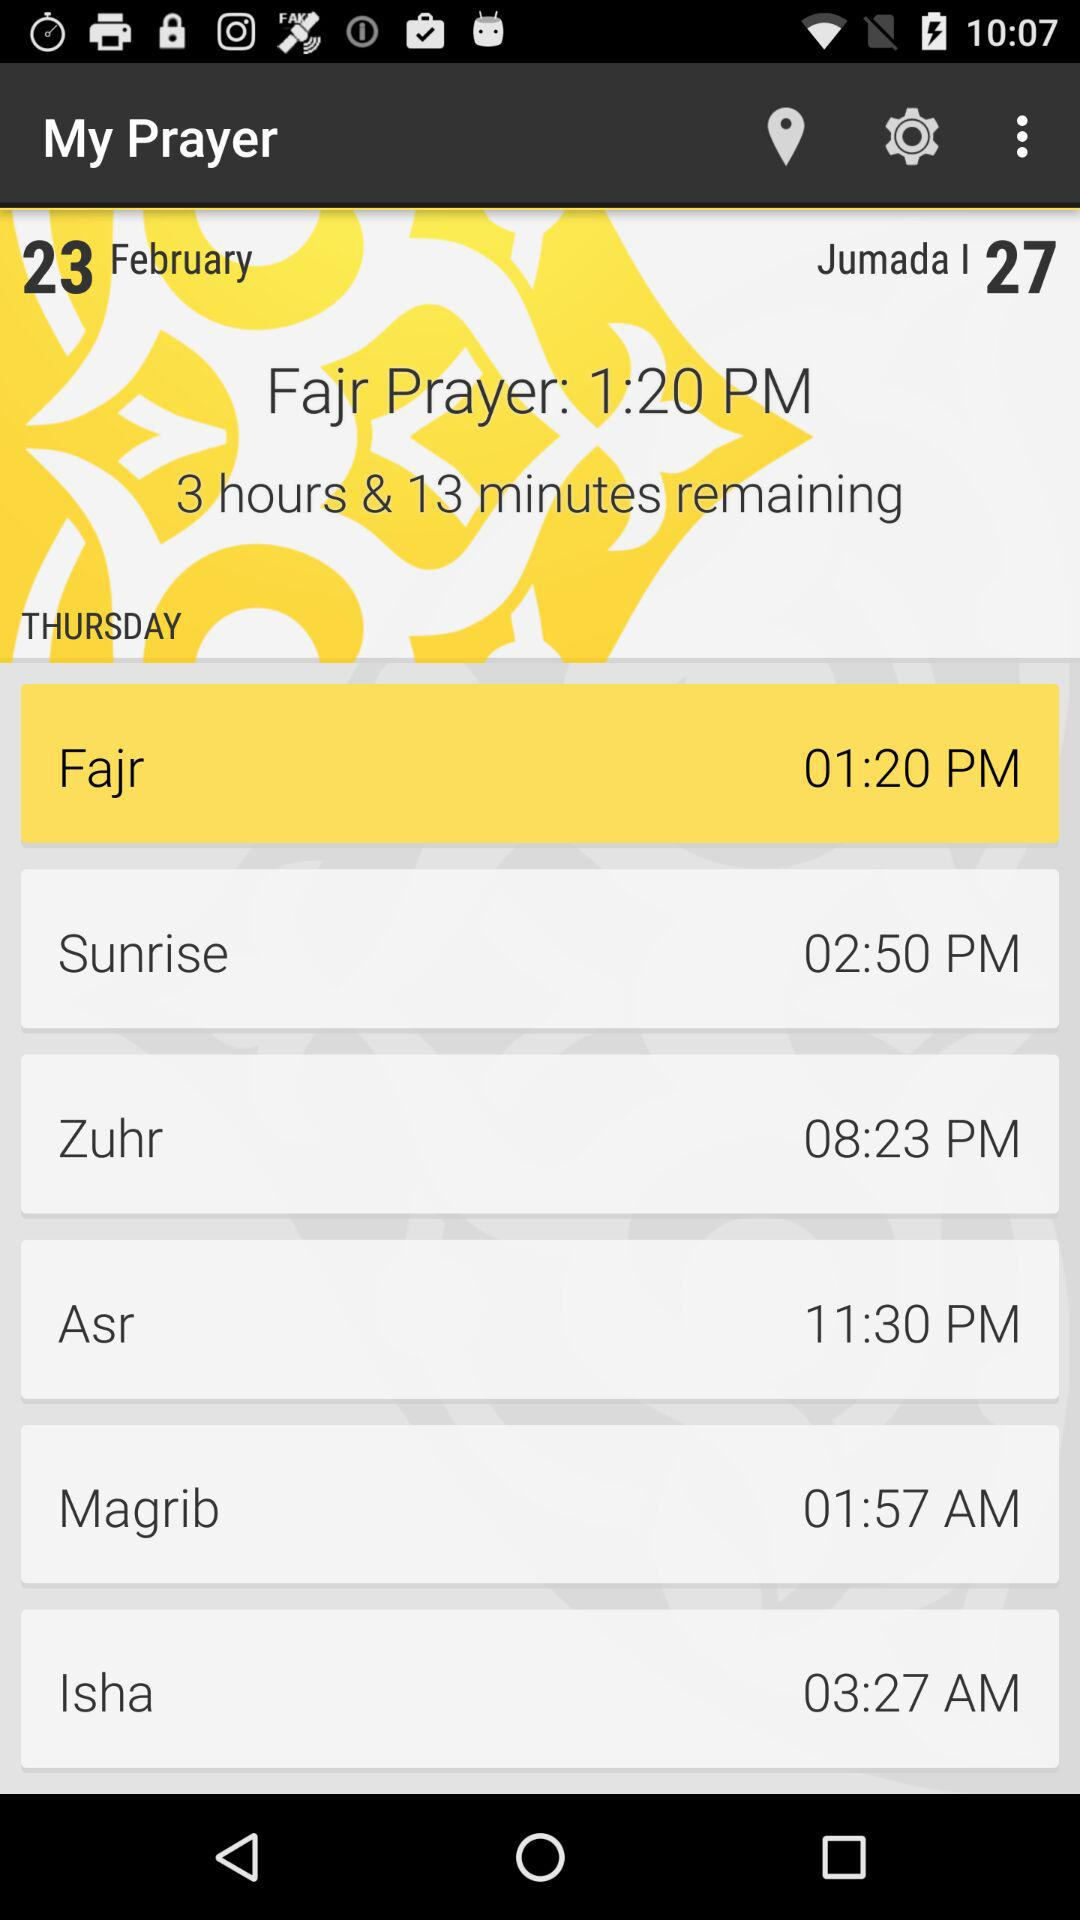What is the time of the "Isha" prayer? The time of the "Isha" prayer is 3:27 AM. 